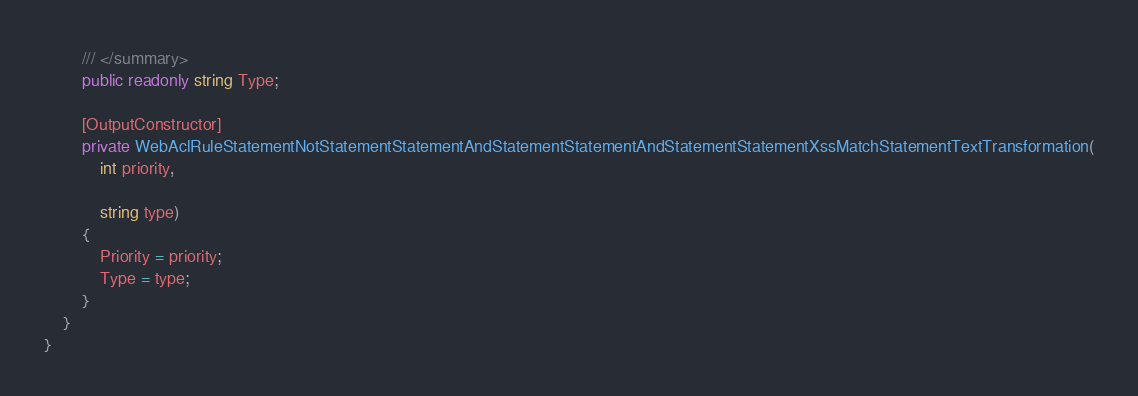Convert code to text. <code><loc_0><loc_0><loc_500><loc_500><_C#_>        /// </summary>
        public readonly string Type;

        [OutputConstructor]
        private WebAclRuleStatementNotStatementStatementAndStatementStatementAndStatementStatementXssMatchStatementTextTransformation(
            int priority,

            string type)
        {
            Priority = priority;
            Type = type;
        }
    }
}
</code> 